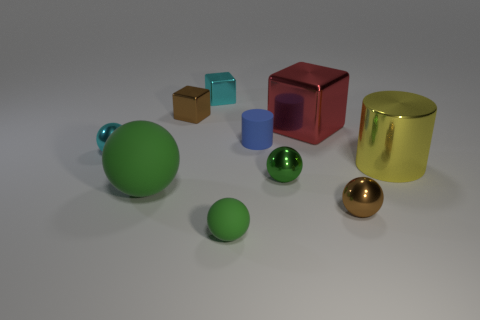How many green spheres must be subtracted to get 2 green spheres? 1 Subtract all gray cubes. How many green spheres are left? 3 Subtract 1 spheres. How many spheres are left? 4 Subtract all small brown shiny spheres. How many spheres are left? 4 Subtract all brown balls. How many balls are left? 4 Subtract all blue spheres. Subtract all blue cylinders. How many spheres are left? 5 Subtract all cylinders. How many objects are left? 8 Subtract all large yellow things. Subtract all tiny rubber cylinders. How many objects are left? 8 Add 4 large red objects. How many large red objects are left? 5 Add 4 purple cubes. How many purple cubes exist? 4 